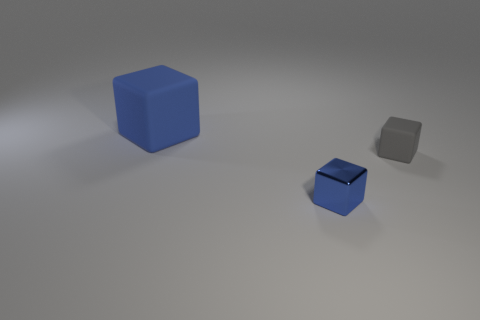Subtract all small blue shiny blocks. How many blocks are left? 2 Subtract 1 blocks. How many blocks are left? 2 Add 1 tiny metal things. How many objects exist? 4 Add 3 tiny blue metallic objects. How many tiny blue metallic objects are left? 4 Add 3 big blue cubes. How many big blue cubes exist? 4 Subtract 0 blue spheres. How many objects are left? 3 Subtract all tiny cyan shiny things. Subtract all shiny things. How many objects are left? 2 